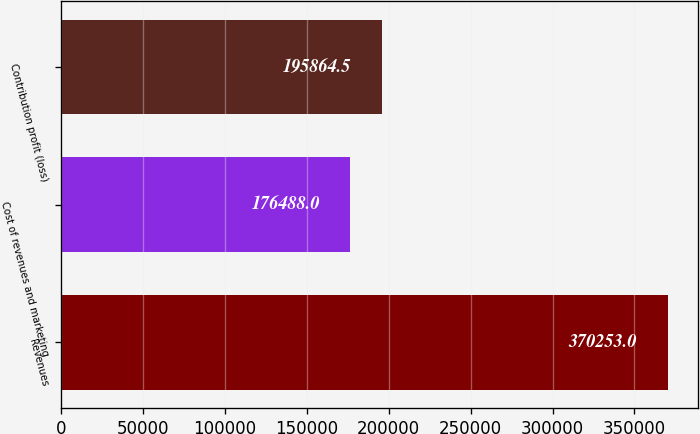<chart> <loc_0><loc_0><loc_500><loc_500><bar_chart><fcel>Revenues<fcel>Cost of revenues and marketing<fcel>Contribution profit (loss)<nl><fcel>370253<fcel>176488<fcel>195864<nl></chart> 